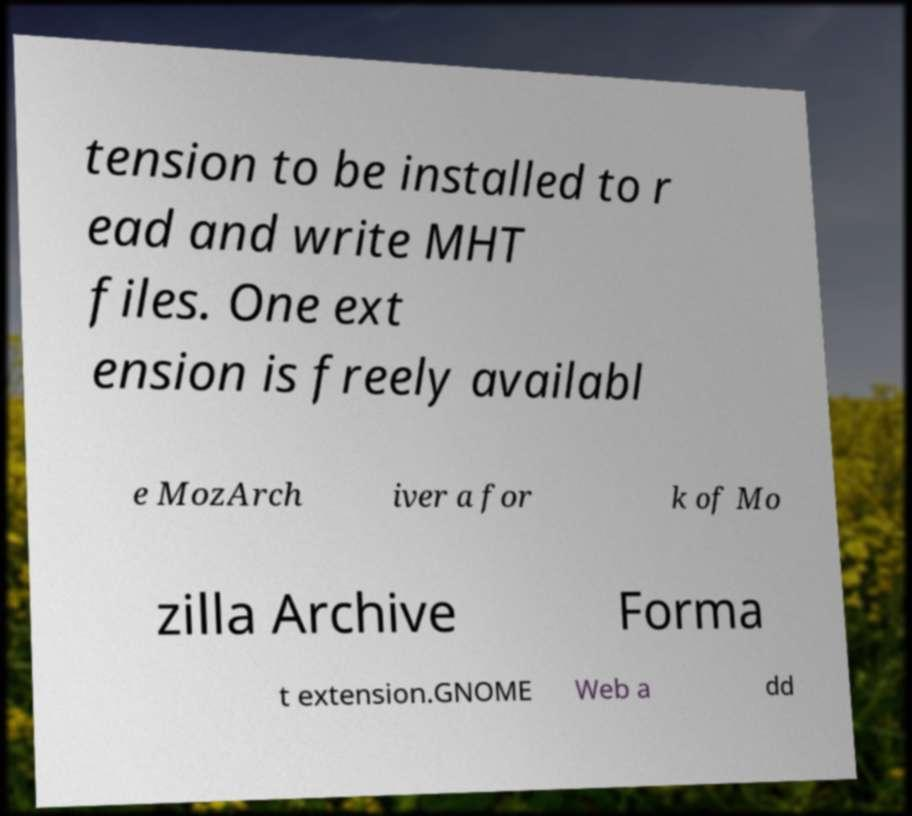I need the written content from this picture converted into text. Can you do that? tension to be installed to r ead and write MHT files. One ext ension is freely availabl e MozArch iver a for k of Mo zilla Archive Forma t extension.GNOME Web a dd 